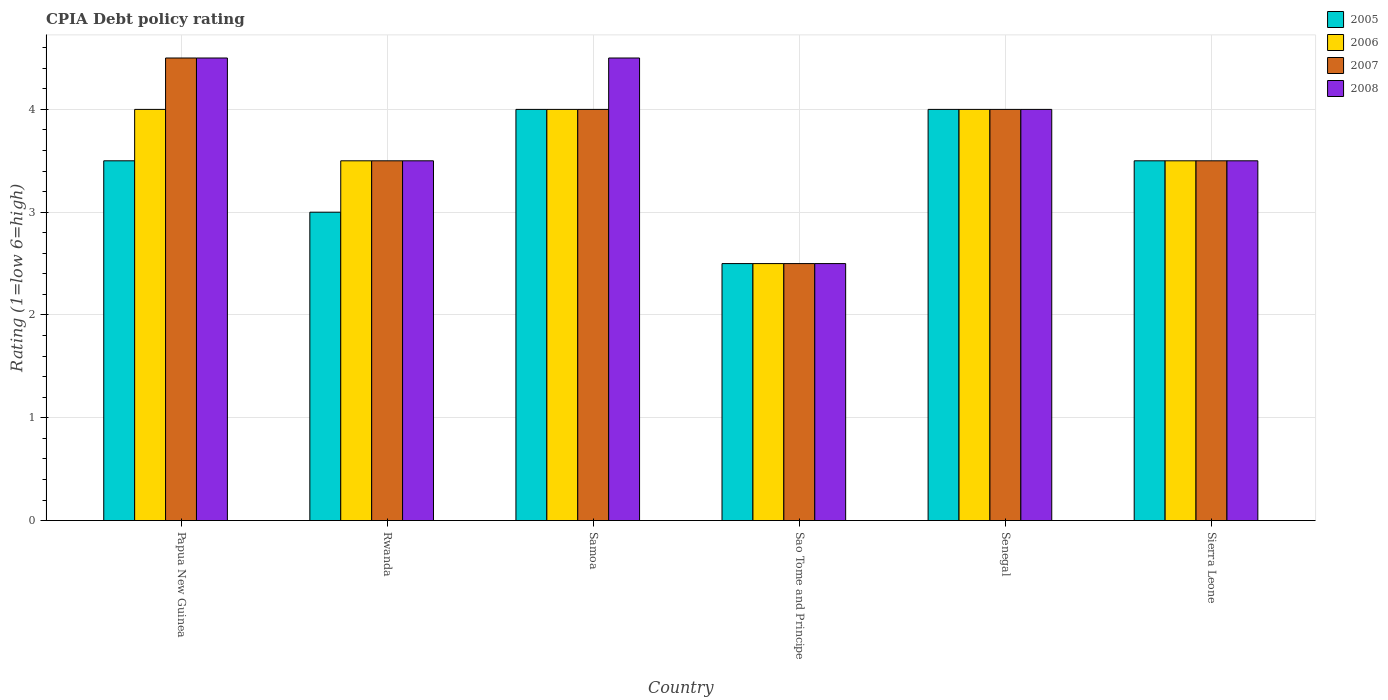How many different coloured bars are there?
Give a very brief answer. 4. How many groups of bars are there?
Provide a short and direct response. 6. Are the number of bars per tick equal to the number of legend labels?
Your answer should be compact. Yes. What is the label of the 4th group of bars from the left?
Offer a very short reply. Sao Tome and Principe. What is the CPIA rating in 2005 in Rwanda?
Your answer should be very brief. 3. Across all countries, what is the minimum CPIA rating in 2006?
Provide a succinct answer. 2.5. In which country was the CPIA rating in 2005 maximum?
Ensure brevity in your answer.  Samoa. In which country was the CPIA rating in 2006 minimum?
Ensure brevity in your answer.  Sao Tome and Principe. What is the difference between the CPIA rating in 2008 in Rwanda and the CPIA rating in 2005 in Papua New Guinea?
Your answer should be compact. 0. What is the average CPIA rating in 2007 per country?
Your answer should be compact. 3.67. What is the difference between the CPIA rating of/in 2008 and CPIA rating of/in 2005 in Rwanda?
Provide a succinct answer. 0.5. What is the ratio of the CPIA rating in 2006 in Samoa to that in Sierra Leone?
Give a very brief answer. 1.14. Is the CPIA rating in 2007 in Samoa less than that in Sierra Leone?
Keep it short and to the point. No. Is the difference between the CPIA rating in 2008 in Sao Tome and Principe and Sierra Leone greater than the difference between the CPIA rating in 2005 in Sao Tome and Principe and Sierra Leone?
Keep it short and to the point. No. What is the difference between the highest and the second highest CPIA rating in 2005?
Offer a terse response. -0.5. What is the difference between the highest and the lowest CPIA rating in 2005?
Offer a terse response. 1.5. Is the sum of the CPIA rating in 2006 in Papua New Guinea and Senegal greater than the maximum CPIA rating in 2008 across all countries?
Offer a terse response. Yes. What does the 3rd bar from the left in Sierra Leone represents?
Provide a succinct answer. 2007. Is it the case that in every country, the sum of the CPIA rating in 2007 and CPIA rating in 2006 is greater than the CPIA rating in 2005?
Your answer should be very brief. Yes. Are all the bars in the graph horizontal?
Your answer should be very brief. No. What is the difference between two consecutive major ticks on the Y-axis?
Give a very brief answer. 1. Does the graph contain any zero values?
Keep it short and to the point. No. Where does the legend appear in the graph?
Make the answer very short. Top right. What is the title of the graph?
Your answer should be compact. CPIA Debt policy rating. Does "1993" appear as one of the legend labels in the graph?
Provide a short and direct response. No. What is the label or title of the Y-axis?
Provide a short and direct response. Rating (1=low 6=high). What is the Rating (1=low 6=high) in 2005 in Papua New Guinea?
Offer a very short reply. 3.5. What is the Rating (1=low 6=high) of 2007 in Papua New Guinea?
Offer a terse response. 4.5. What is the Rating (1=low 6=high) in 2008 in Papua New Guinea?
Provide a succinct answer. 4.5. What is the Rating (1=low 6=high) in 2005 in Rwanda?
Ensure brevity in your answer.  3. What is the Rating (1=low 6=high) of 2007 in Rwanda?
Make the answer very short. 3.5. What is the Rating (1=low 6=high) in 2008 in Rwanda?
Provide a short and direct response. 3.5. What is the Rating (1=low 6=high) of 2005 in Samoa?
Provide a succinct answer. 4. What is the Rating (1=low 6=high) in 2005 in Sao Tome and Principe?
Make the answer very short. 2.5. What is the Rating (1=low 6=high) in 2006 in Senegal?
Provide a short and direct response. 4. What is the Rating (1=low 6=high) in 2007 in Senegal?
Ensure brevity in your answer.  4. What is the Rating (1=low 6=high) of 2005 in Sierra Leone?
Your response must be concise. 3.5. What is the Rating (1=low 6=high) in 2006 in Sierra Leone?
Offer a very short reply. 3.5. What is the Rating (1=low 6=high) of 2008 in Sierra Leone?
Ensure brevity in your answer.  3.5. Across all countries, what is the maximum Rating (1=low 6=high) in 2006?
Keep it short and to the point. 4. Across all countries, what is the maximum Rating (1=low 6=high) of 2007?
Keep it short and to the point. 4.5. Across all countries, what is the minimum Rating (1=low 6=high) in 2005?
Ensure brevity in your answer.  2.5. Across all countries, what is the minimum Rating (1=low 6=high) in 2007?
Your answer should be compact. 2.5. Across all countries, what is the minimum Rating (1=low 6=high) in 2008?
Provide a succinct answer. 2.5. What is the total Rating (1=low 6=high) in 2006 in the graph?
Your answer should be very brief. 21.5. What is the total Rating (1=low 6=high) in 2007 in the graph?
Keep it short and to the point. 22. What is the total Rating (1=low 6=high) of 2008 in the graph?
Provide a short and direct response. 22.5. What is the difference between the Rating (1=low 6=high) of 2005 in Papua New Guinea and that in Rwanda?
Keep it short and to the point. 0.5. What is the difference between the Rating (1=low 6=high) in 2006 in Papua New Guinea and that in Rwanda?
Provide a short and direct response. 0.5. What is the difference between the Rating (1=low 6=high) of 2006 in Papua New Guinea and that in Samoa?
Give a very brief answer. 0. What is the difference between the Rating (1=low 6=high) of 2007 in Papua New Guinea and that in Samoa?
Provide a short and direct response. 0.5. What is the difference between the Rating (1=low 6=high) in 2008 in Papua New Guinea and that in Samoa?
Offer a very short reply. 0. What is the difference between the Rating (1=low 6=high) in 2005 in Papua New Guinea and that in Sao Tome and Principe?
Your answer should be compact. 1. What is the difference between the Rating (1=low 6=high) of 2008 in Papua New Guinea and that in Sao Tome and Principe?
Provide a short and direct response. 2. What is the difference between the Rating (1=low 6=high) of 2006 in Papua New Guinea and that in Senegal?
Provide a short and direct response. 0. What is the difference between the Rating (1=low 6=high) in 2007 in Papua New Guinea and that in Senegal?
Offer a terse response. 0.5. What is the difference between the Rating (1=low 6=high) in 2008 in Papua New Guinea and that in Senegal?
Give a very brief answer. 0.5. What is the difference between the Rating (1=low 6=high) in 2005 in Papua New Guinea and that in Sierra Leone?
Your response must be concise. 0. What is the difference between the Rating (1=low 6=high) in 2006 in Papua New Guinea and that in Sierra Leone?
Your answer should be very brief. 0.5. What is the difference between the Rating (1=low 6=high) in 2006 in Rwanda and that in Samoa?
Provide a short and direct response. -0.5. What is the difference between the Rating (1=low 6=high) in 2007 in Rwanda and that in Sao Tome and Principe?
Your answer should be compact. 1. What is the difference between the Rating (1=low 6=high) of 2007 in Rwanda and that in Senegal?
Your response must be concise. -0.5. What is the difference between the Rating (1=low 6=high) in 2008 in Rwanda and that in Senegal?
Offer a very short reply. -0.5. What is the difference between the Rating (1=low 6=high) in 2006 in Rwanda and that in Sierra Leone?
Give a very brief answer. 0. What is the difference between the Rating (1=low 6=high) of 2008 in Rwanda and that in Sierra Leone?
Give a very brief answer. 0. What is the difference between the Rating (1=low 6=high) in 2006 in Samoa and that in Sao Tome and Principe?
Your answer should be very brief. 1.5. What is the difference between the Rating (1=low 6=high) in 2007 in Samoa and that in Sao Tome and Principe?
Offer a very short reply. 1.5. What is the difference between the Rating (1=low 6=high) of 2008 in Samoa and that in Sao Tome and Principe?
Your response must be concise. 2. What is the difference between the Rating (1=low 6=high) in 2005 in Samoa and that in Senegal?
Provide a succinct answer. 0. What is the difference between the Rating (1=low 6=high) in 2007 in Samoa and that in Senegal?
Your response must be concise. 0. What is the difference between the Rating (1=low 6=high) in 2006 in Samoa and that in Sierra Leone?
Make the answer very short. 0.5. What is the difference between the Rating (1=low 6=high) of 2008 in Samoa and that in Sierra Leone?
Provide a short and direct response. 1. What is the difference between the Rating (1=low 6=high) of 2005 in Sao Tome and Principe and that in Senegal?
Ensure brevity in your answer.  -1.5. What is the difference between the Rating (1=low 6=high) of 2006 in Sao Tome and Principe and that in Senegal?
Provide a succinct answer. -1.5. What is the difference between the Rating (1=low 6=high) in 2007 in Sao Tome and Principe and that in Senegal?
Make the answer very short. -1.5. What is the difference between the Rating (1=low 6=high) in 2005 in Sao Tome and Principe and that in Sierra Leone?
Ensure brevity in your answer.  -1. What is the difference between the Rating (1=low 6=high) in 2005 in Senegal and that in Sierra Leone?
Provide a short and direct response. 0.5. What is the difference between the Rating (1=low 6=high) in 2006 in Senegal and that in Sierra Leone?
Keep it short and to the point. 0.5. What is the difference between the Rating (1=low 6=high) in 2007 in Senegal and that in Sierra Leone?
Offer a terse response. 0.5. What is the difference between the Rating (1=low 6=high) of 2008 in Senegal and that in Sierra Leone?
Provide a short and direct response. 0.5. What is the difference between the Rating (1=low 6=high) of 2005 in Papua New Guinea and the Rating (1=low 6=high) of 2006 in Rwanda?
Offer a terse response. 0. What is the difference between the Rating (1=low 6=high) in 2005 in Papua New Guinea and the Rating (1=low 6=high) in 2007 in Rwanda?
Offer a very short reply. 0. What is the difference between the Rating (1=low 6=high) in 2005 in Papua New Guinea and the Rating (1=low 6=high) in 2008 in Rwanda?
Ensure brevity in your answer.  0. What is the difference between the Rating (1=low 6=high) in 2006 in Papua New Guinea and the Rating (1=low 6=high) in 2008 in Rwanda?
Provide a succinct answer. 0.5. What is the difference between the Rating (1=low 6=high) in 2007 in Papua New Guinea and the Rating (1=low 6=high) in 2008 in Rwanda?
Provide a short and direct response. 1. What is the difference between the Rating (1=low 6=high) in 2005 in Papua New Guinea and the Rating (1=low 6=high) in 2008 in Samoa?
Offer a terse response. -1. What is the difference between the Rating (1=low 6=high) in 2006 in Papua New Guinea and the Rating (1=low 6=high) in 2007 in Samoa?
Your answer should be very brief. 0. What is the difference between the Rating (1=low 6=high) of 2006 in Papua New Guinea and the Rating (1=low 6=high) of 2008 in Samoa?
Provide a short and direct response. -0.5. What is the difference between the Rating (1=low 6=high) of 2005 in Papua New Guinea and the Rating (1=low 6=high) of 2006 in Sao Tome and Principe?
Keep it short and to the point. 1. What is the difference between the Rating (1=low 6=high) in 2005 in Papua New Guinea and the Rating (1=low 6=high) in 2007 in Sao Tome and Principe?
Provide a short and direct response. 1. What is the difference between the Rating (1=low 6=high) in 2005 in Papua New Guinea and the Rating (1=low 6=high) in 2008 in Sao Tome and Principe?
Keep it short and to the point. 1. What is the difference between the Rating (1=low 6=high) of 2006 in Papua New Guinea and the Rating (1=low 6=high) of 2007 in Sao Tome and Principe?
Offer a terse response. 1.5. What is the difference between the Rating (1=low 6=high) of 2006 in Papua New Guinea and the Rating (1=low 6=high) of 2008 in Sao Tome and Principe?
Make the answer very short. 1.5. What is the difference between the Rating (1=low 6=high) in 2007 in Papua New Guinea and the Rating (1=low 6=high) in 2008 in Sao Tome and Principe?
Provide a short and direct response. 2. What is the difference between the Rating (1=low 6=high) of 2005 in Papua New Guinea and the Rating (1=low 6=high) of 2006 in Senegal?
Make the answer very short. -0.5. What is the difference between the Rating (1=low 6=high) in 2005 in Papua New Guinea and the Rating (1=low 6=high) in 2007 in Senegal?
Ensure brevity in your answer.  -0.5. What is the difference between the Rating (1=low 6=high) of 2006 in Papua New Guinea and the Rating (1=low 6=high) of 2008 in Senegal?
Your answer should be compact. 0. What is the difference between the Rating (1=low 6=high) in 2005 in Papua New Guinea and the Rating (1=low 6=high) in 2006 in Sierra Leone?
Offer a terse response. 0. What is the difference between the Rating (1=low 6=high) in 2005 in Papua New Guinea and the Rating (1=low 6=high) in 2007 in Sierra Leone?
Your answer should be very brief. 0. What is the difference between the Rating (1=low 6=high) of 2005 in Papua New Guinea and the Rating (1=low 6=high) of 2008 in Sierra Leone?
Your answer should be compact. 0. What is the difference between the Rating (1=low 6=high) in 2006 in Papua New Guinea and the Rating (1=low 6=high) in 2008 in Sierra Leone?
Ensure brevity in your answer.  0.5. What is the difference between the Rating (1=low 6=high) of 2007 in Papua New Guinea and the Rating (1=low 6=high) of 2008 in Sierra Leone?
Make the answer very short. 1. What is the difference between the Rating (1=low 6=high) of 2005 in Rwanda and the Rating (1=low 6=high) of 2007 in Samoa?
Provide a short and direct response. -1. What is the difference between the Rating (1=low 6=high) of 2005 in Rwanda and the Rating (1=low 6=high) of 2008 in Samoa?
Provide a succinct answer. -1.5. What is the difference between the Rating (1=low 6=high) in 2006 in Rwanda and the Rating (1=low 6=high) in 2007 in Samoa?
Ensure brevity in your answer.  -0.5. What is the difference between the Rating (1=low 6=high) in 2007 in Rwanda and the Rating (1=low 6=high) in 2008 in Samoa?
Offer a very short reply. -1. What is the difference between the Rating (1=low 6=high) of 2007 in Rwanda and the Rating (1=low 6=high) of 2008 in Sao Tome and Principe?
Offer a very short reply. 1. What is the difference between the Rating (1=low 6=high) of 2005 in Rwanda and the Rating (1=low 6=high) of 2007 in Sierra Leone?
Ensure brevity in your answer.  -0.5. What is the difference between the Rating (1=low 6=high) in 2005 in Rwanda and the Rating (1=low 6=high) in 2008 in Sierra Leone?
Make the answer very short. -0.5. What is the difference between the Rating (1=low 6=high) of 2006 in Rwanda and the Rating (1=low 6=high) of 2008 in Sierra Leone?
Your response must be concise. 0. What is the difference between the Rating (1=low 6=high) of 2005 in Samoa and the Rating (1=low 6=high) of 2007 in Sao Tome and Principe?
Offer a terse response. 1.5. What is the difference between the Rating (1=low 6=high) of 2006 in Samoa and the Rating (1=low 6=high) of 2007 in Sao Tome and Principe?
Your answer should be compact. 1.5. What is the difference between the Rating (1=low 6=high) of 2006 in Samoa and the Rating (1=low 6=high) of 2008 in Sao Tome and Principe?
Make the answer very short. 1.5. What is the difference between the Rating (1=low 6=high) in 2005 in Samoa and the Rating (1=low 6=high) in 2008 in Senegal?
Your response must be concise. 0. What is the difference between the Rating (1=low 6=high) in 2005 in Samoa and the Rating (1=low 6=high) in 2007 in Sierra Leone?
Ensure brevity in your answer.  0.5. What is the difference between the Rating (1=low 6=high) of 2007 in Samoa and the Rating (1=low 6=high) of 2008 in Sierra Leone?
Offer a very short reply. 0.5. What is the difference between the Rating (1=low 6=high) in 2005 in Sao Tome and Principe and the Rating (1=low 6=high) in 2008 in Senegal?
Make the answer very short. -1.5. What is the difference between the Rating (1=low 6=high) of 2006 in Sao Tome and Principe and the Rating (1=low 6=high) of 2008 in Senegal?
Make the answer very short. -1.5. What is the difference between the Rating (1=low 6=high) of 2005 in Sao Tome and Principe and the Rating (1=low 6=high) of 2006 in Sierra Leone?
Ensure brevity in your answer.  -1. What is the difference between the Rating (1=low 6=high) of 2005 in Sao Tome and Principe and the Rating (1=low 6=high) of 2007 in Sierra Leone?
Keep it short and to the point. -1. What is the difference between the Rating (1=low 6=high) of 2005 in Sao Tome and Principe and the Rating (1=low 6=high) of 2008 in Sierra Leone?
Offer a very short reply. -1. What is the difference between the Rating (1=low 6=high) of 2006 in Sao Tome and Principe and the Rating (1=low 6=high) of 2007 in Sierra Leone?
Make the answer very short. -1. What is the difference between the Rating (1=low 6=high) in 2006 in Sao Tome and Principe and the Rating (1=low 6=high) in 2008 in Sierra Leone?
Give a very brief answer. -1. What is the difference between the Rating (1=low 6=high) of 2005 in Senegal and the Rating (1=low 6=high) of 2007 in Sierra Leone?
Make the answer very short. 0.5. What is the difference between the Rating (1=low 6=high) in 2005 in Senegal and the Rating (1=low 6=high) in 2008 in Sierra Leone?
Your answer should be very brief. 0.5. What is the difference between the Rating (1=low 6=high) of 2006 in Senegal and the Rating (1=low 6=high) of 2007 in Sierra Leone?
Your answer should be compact. 0.5. What is the difference between the Rating (1=low 6=high) of 2006 in Senegal and the Rating (1=low 6=high) of 2008 in Sierra Leone?
Your response must be concise. 0.5. What is the average Rating (1=low 6=high) in 2005 per country?
Your response must be concise. 3.42. What is the average Rating (1=low 6=high) in 2006 per country?
Provide a succinct answer. 3.58. What is the average Rating (1=low 6=high) in 2007 per country?
Offer a terse response. 3.67. What is the average Rating (1=low 6=high) of 2008 per country?
Make the answer very short. 3.75. What is the difference between the Rating (1=low 6=high) in 2005 and Rating (1=low 6=high) in 2006 in Papua New Guinea?
Your answer should be very brief. -0.5. What is the difference between the Rating (1=low 6=high) of 2005 and Rating (1=low 6=high) of 2007 in Papua New Guinea?
Offer a terse response. -1. What is the difference between the Rating (1=low 6=high) of 2006 and Rating (1=low 6=high) of 2008 in Papua New Guinea?
Provide a succinct answer. -0.5. What is the difference between the Rating (1=low 6=high) in 2005 and Rating (1=low 6=high) in 2007 in Rwanda?
Provide a succinct answer. -0.5. What is the difference between the Rating (1=low 6=high) of 2006 and Rating (1=low 6=high) of 2007 in Rwanda?
Keep it short and to the point. 0. What is the difference between the Rating (1=low 6=high) of 2006 and Rating (1=low 6=high) of 2008 in Rwanda?
Make the answer very short. 0. What is the difference between the Rating (1=low 6=high) of 2006 and Rating (1=low 6=high) of 2007 in Samoa?
Your answer should be very brief. 0. What is the difference between the Rating (1=low 6=high) in 2007 and Rating (1=low 6=high) in 2008 in Samoa?
Your response must be concise. -0.5. What is the difference between the Rating (1=low 6=high) in 2005 and Rating (1=low 6=high) in 2007 in Sao Tome and Principe?
Offer a very short reply. 0. What is the difference between the Rating (1=low 6=high) in 2005 and Rating (1=low 6=high) in 2008 in Sao Tome and Principe?
Your response must be concise. 0. What is the difference between the Rating (1=low 6=high) of 2006 and Rating (1=low 6=high) of 2008 in Sao Tome and Principe?
Your answer should be very brief. 0. What is the difference between the Rating (1=low 6=high) in 2007 and Rating (1=low 6=high) in 2008 in Sao Tome and Principe?
Keep it short and to the point. 0. What is the difference between the Rating (1=low 6=high) in 2005 and Rating (1=low 6=high) in 2007 in Senegal?
Give a very brief answer. 0. What is the difference between the Rating (1=low 6=high) of 2005 and Rating (1=low 6=high) of 2008 in Senegal?
Your answer should be compact. 0. What is the difference between the Rating (1=low 6=high) of 2006 and Rating (1=low 6=high) of 2007 in Senegal?
Offer a very short reply. 0. What is the difference between the Rating (1=low 6=high) in 2006 and Rating (1=low 6=high) in 2008 in Senegal?
Make the answer very short. 0. What is the difference between the Rating (1=low 6=high) in 2005 and Rating (1=low 6=high) in 2006 in Sierra Leone?
Offer a very short reply. 0. What is the difference between the Rating (1=low 6=high) in 2005 and Rating (1=low 6=high) in 2007 in Sierra Leone?
Give a very brief answer. 0. What is the difference between the Rating (1=low 6=high) of 2005 and Rating (1=low 6=high) of 2008 in Sierra Leone?
Provide a succinct answer. 0. What is the ratio of the Rating (1=low 6=high) of 2005 in Papua New Guinea to that in Rwanda?
Give a very brief answer. 1.17. What is the ratio of the Rating (1=low 6=high) of 2006 in Papua New Guinea to that in Rwanda?
Your answer should be compact. 1.14. What is the ratio of the Rating (1=low 6=high) of 2007 in Papua New Guinea to that in Rwanda?
Offer a terse response. 1.29. What is the ratio of the Rating (1=low 6=high) in 2007 in Papua New Guinea to that in Samoa?
Offer a very short reply. 1.12. What is the ratio of the Rating (1=low 6=high) of 2005 in Papua New Guinea to that in Sao Tome and Principe?
Your answer should be compact. 1.4. What is the ratio of the Rating (1=low 6=high) of 2006 in Papua New Guinea to that in Senegal?
Your answer should be compact. 1. What is the ratio of the Rating (1=low 6=high) in 2007 in Papua New Guinea to that in Senegal?
Ensure brevity in your answer.  1.12. What is the ratio of the Rating (1=low 6=high) of 2008 in Papua New Guinea to that in Senegal?
Make the answer very short. 1.12. What is the ratio of the Rating (1=low 6=high) of 2005 in Papua New Guinea to that in Sierra Leone?
Keep it short and to the point. 1. What is the ratio of the Rating (1=low 6=high) of 2006 in Rwanda to that in Samoa?
Your answer should be very brief. 0.88. What is the ratio of the Rating (1=low 6=high) of 2007 in Rwanda to that in Samoa?
Your answer should be compact. 0.88. What is the ratio of the Rating (1=low 6=high) of 2008 in Rwanda to that in Samoa?
Give a very brief answer. 0.78. What is the ratio of the Rating (1=low 6=high) of 2006 in Rwanda to that in Sao Tome and Principe?
Keep it short and to the point. 1.4. What is the ratio of the Rating (1=low 6=high) of 2008 in Rwanda to that in Sao Tome and Principe?
Offer a terse response. 1.4. What is the ratio of the Rating (1=low 6=high) in 2005 in Rwanda to that in Senegal?
Make the answer very short. 0.75. What is the ratio of the Rating (1=low 6=high) in 2006 in Rwanda to that in Senegal?
Give a very brief answer. 0.88. What is the ratio of the Rating (1=low 6=high) of 2008 in Rwanda to that in Senegal?
Offer a terse response. 0.88. What is the ratio of the Rating (1=low 6=high) in 2006 in Rwanda to that in Sierra Leone?
Your response must be concise. 1. What is the ratio of the Rating (1=low 6=high) of 2007 in Rwanda to that in Sierra Leone?
Offer a terse response. 1. What is the ratio of the Rating (1=low 6=high) in 2008 in Rwanda to that in Sierra Leone?
Ensure brevity in your answer.  1. What is the ratio of the Rating (1=low 6=high) in 2007 in Samoa to that in Sao Tome and Principe?
Your response must be concise. 1.6. What is the ratio of the Rating (1=low 6=high) of 2007 in Samoa to that in Senegal?
Ensure brevity in your answer.  1. What is the ratio of the Rating (1=low 6=high) in 2008 in Samoa to that in Senegal?
Your answer should be very brief. 1.12. What is the ratio of the Rating (1=low 6=high) in 2006 in Samoa to that in Sierra Leone?
Your response must be concise. 1.14. What is the ratio of the Rating (1=low 6=high) of 2005 in Sao Tome and Principe to that in Senegal?
Provide a short and direct response. 0.62. What is the ratio of the Rating (1=low 6=high) in 2006 in Sao Tome and Principe to that in Senegal?
Offer a very short reply. 0.62. What is the ratio of the Rating (1=low 6=high) of 2008 in Sao Tome and Principe to that in Senegal?
Provide a short and direct response. 0.62. What is the ratio of the Rating (1=low 6=high) of 2006 in Sao Tome and Principe to that in Sierra Leone?
Offer a very short reply. 0.71. What is the ratio of the Rating (1=low 6=high) of 2008 in Sao Tome and Principe to that in Sierra Leone?
Make the answer very short. 0.71. What is the ratio of the Rating (1=low 6=high) in 2007 in Senegal to that in Sierra Leone?
Keep it short and to the point. 1.14. What is the ratio of the Rating (1=low 6=high) of 2008 in Senegal to that in Sierra Leone?
Provide a succinct answer. 1.14. What is the difference between the highest and the second highest Rating (1=low 6=high) in 2005?
Keep it short and to the point. 0. What is the difference between the highest and the second highest Rating (1=low 6=high) of 2007?
Keep it short and to the point. 0.5. What is the difference between the highest and the second highest Rating (1=low 6=high) of 2008?
Offer a terse response. 0. What is the difference between the highest and the lowest Rating (1=low 6=high) in 2006?
Provide a succinct answer. 1.5. What is the difference between the highest and the lowest Rating (1=low 6=high) of 2007?
Your answer should be very brief. 2. 